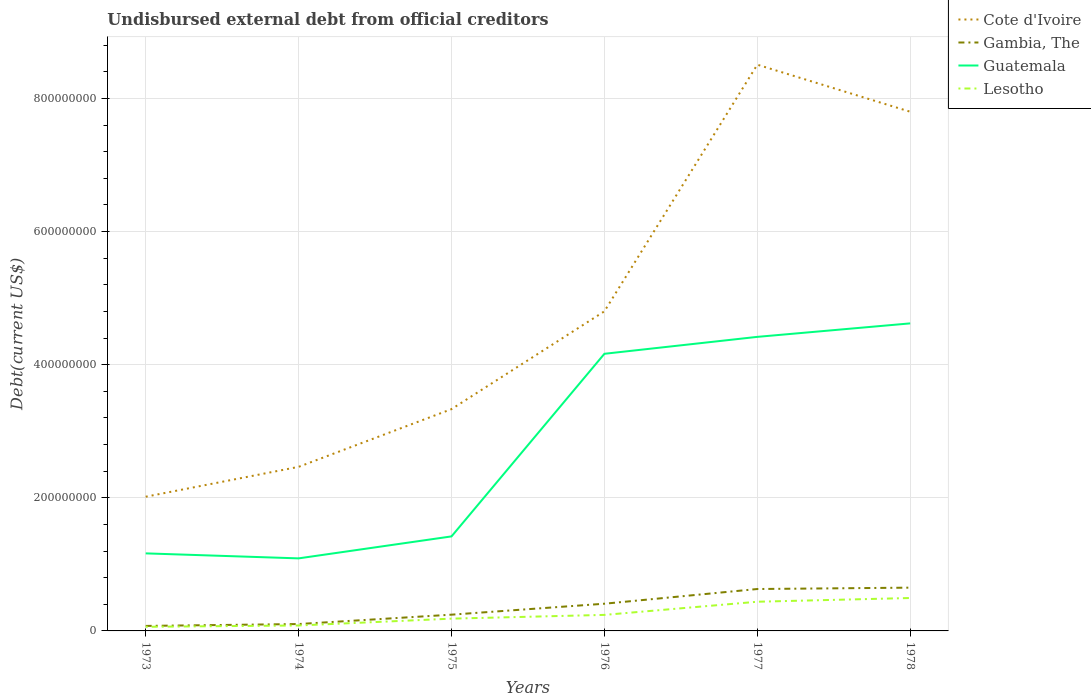How many different coloured lines are there?
Provide a short and direct response. 4. Is the number of lines equal to the number of legend labels?
Offer a very short reply. Yes. Across all years, what is the maximum total debt in Cote d'Ivoire?
Provide a short and direct response. 2.02e+08. What is the total total debt in Gambia, The in the graph?
Provide a short and direct response. -2.83e+06. What is the difference between the highest and the second highest total debt in Guatemala?
Offer a terse response. 3.53e+08. How many lines are there?
Ensure brevity in your answer.  4. Are the values on the major ticks of Y-axis written in scientific E-notation?
Your response must be concise. No. Where does the legend appear in the graph?
Offer a very short reply. Top right. How are the legend labels stacked?
Give a very brief answer. Vertical. What is the title of the graph?
Your answer should be very brief. Undisbursed external debt from official creditors. What is the label or title of the Y-axis?
Give a very brief answer. Debt(current US$). What is the Debt(current US$) in Cote d'Ivoire in 1973?
Keep it short and to the point. 2.02e+08. What is the Debt(current US$) in Gambia, The in 1973?
Ensure brevity in your answer.  7.52e+06. What is the Debt(current US$) of Guatemala in 1973?
Offer a very short reply. 1.17e+08. What is the Debt(current US$) in Lesotho in 1973?
Give a very brief answer. 6.19e+06. What is the Debt(current US$) of Cote d'Ivoire in 1974?
Give a very brief answer. 2.47e+08. What is the Debt(current US$) of Gambia, The in 1974?
Give a very brief answer. 1.03e+07. What is the Debt(current US$) in Guatemala in 1974?
Provide a succinct answer. 1.09e+08. What is the Debt(current US$) of Lesotho in 1974?
Make the answer very short. 8.19e+06. What is the Debt(current US$) in Cote d'Ivoire in 1975?
Your answer should be compact. 3.33e+08. What is the Debt(current US$) in Gambia, The in 1975?
Offer a very short reply. 2.44e+07. What is the Debt(current US$) in Guatemala in 1975?
Ensure brevity in your answer.  1.42e+08. What is the Debt(current US$) of Lesotho in 1975?
Give a very brief answer. 1.85e+07. What is the Debt(current US$) of Cote d'Ivoire in 1976?
Give a very brief answer. 4.80e+08. What is the Debt(current US$) in Gambia, The in 1976?
Your answer should be very brief. 4.09e+07. What is the Debt(current US$) of Guatemala in 1976?
Offer a terse response. 4.16e+08. What is the Debt(current US$) of Lesotho in 1976?
Keep it short and to the point. 2.41e+07. What is the Debt(current US$) in Cote d'Ivoire in 1977?
Give a very brief answer. 8.51e+08. What is the Debt(current US$) in Gambia, The in 1977?
Your response must be concise. 6.30e+07. What is the Debt(current US$) of Guatemala in 1977?
Your response must be concise. 4.42e+08. What is the Debt(current US$) in Lesotho in 1977?
Keep it short and to the point. 4.39e+07. What is the Debt(current US$) of Cote d'Ivoire in 1978?
Offer a very short reply. 7.80e+08. What is the Debt(current US$) of Gambia, The in 1978?
Offer a terse response. 6.50e+07. What is the Debt(current US$) in Guatemala in 1978?
Your answer should be very brief. 4.62e+08. What is the Debt(current US$) in Lesotho in 1978?
Provide a short and direct response. 4.95e+07. Across all years, what is the maximum Debt(current US$) of Cote d'Ivoire?
Give a very brief answer. 8.51e+08. Across all years, what is the maximum Debt(current US$) of Gambia, The?
Ensure brevity in your answer.  6.50e+07. Across all years, what is the maximum Debt(current US$) in Guatemala?
Provide a short and direct response. 4.62e+08. Across all years, what is the maximum Debt(current US$) in Lesotho?
Ensure brevity in your answer.  4.95e+07. Across all years, what is the minimum Debt(current US$) in Cote d'Ivoire?
Provide a short and direct response. 2.02e+08. Across all years, what is the minimum Debt(current US$) of Gambia, The?
Provide a short and direct response. 7.52e+06. Across all years, what is the minimum Debt(current US$) in Guatemala?
Ensure brevity in your answer.  1.09e+08. Across all years, what is the minimum Debt(current US$) of Lesotho?
Your response must be concise. 6.19e+06. What is the total Debt(current US$) in Cote d'Ivoire in the graph?
Provide a short and direct response. 2.89e+09. What is the total Debt(current US$) in Gambia, The in the graph?
Your answer should be compact. 2.11e+08. What is the total Debt(current US$) in Guatemala in the graph?
Your answer should be compact. 1.69e+09. What is the total Debt(current US$) of Lesotho in the graph?
Ensure brevity in your answer.  1.50e+08. What is the difference between the Debt(current US$) in Cote d'Ivoire in 1973 and that in 1974?
Provide a succinct answer. -4.49e+07. What is the difference between the Debt(current US$) in Gambia, The in 1973 and that in 1974?
Offer a very short reply. -2.83e+06. What is the difference between the Debt(current US$) of Guatemala in 1973 and that in 1974?
Keep it short and to the point. 7.50e+06. What is the difference between the Debt(current US$) in Lesotho in 1973 and that in 1974?
Provide a succinct answer. -2.00e+06. What is the difference between the Debt(current US$) in Cote d'Ivoire in 1973 and that in 1975?
Offer a terse response. -1.32e+08. What is the difference between the Debt(current US$) of Gambia, The in 1973 and that in 1975?
Your response must be concise. -1.69e+07. What is the difference between the Debt(current US$) in Guatemala in 1973 and that in 1975?
Provide a short and direct response. -2.55e+07. What is the difference between the Debt(current US$) of Lesotho in 1973 and that in 1975?
Your answer should be very brief. -1.23e+07. What is the difference between the Debt(current US$) in Cote d'Ivoire in 1973 and that in 1976?
Make the answer very short. -2.79e+08. What is the difference between the Debt(current US$) of Gambia, The in 1973 and that in 1976?
Make the answer very short. -3.34e+07. What is the difference between the Debt(current US$) of Guatemala in 1973 and that in 1976?
Your response must be concise. -3.00e+08. What is the difference between the Debt(current US$) of Lesotho in 1973 and that in 1976?
Make the answer very short. -1.79e+07. What is the difference between the Debt(current US$) in Cote d'Ivoire in 1973 and that in 1977?
Give a very brief answer. -6.49e+08. What is the difference between the Debt(current US$) in Gambia, The in 1973 and that in 1977?
Ensure brevity in your answer.  -5.54e+07. What is the difference between the Debt(current US$) of Guatemala in 1973 and that in 1977?
Give a very brief answer. -3.25e+08. What is the difference between the Debt(current US$) in Lesotho in 1973 and that in 1977?
Your response must be concise. -3.77e+07. What is the difference between the Debt(current US$) in Cote d'Ivoire in 1973 and that in 1978?
Ensure brevity in your answer.  -5.78e+08. What is the difference between the Debt(current US$) in Gambia, The in 1973 and that in 1978?
Your response must be concise. -5.75e+07. What is the difference between the Debt(current US$) in Guatemala in 1973 and that in 1978?
Ensure brevity in your answer.  -3.46e+08. What is the difference between the Debt(current US$) of Lesotho in 1973 and that in 1978?
Your answer should be very brief. -4.33e+07. What is the difference between the Debt(current US$) of Cote d'Ivoire in 1974 and that in 1975?
Offer a very short reply. -8.67e+07. What is the difference between the Debt(current US$) in Gambia, The in 1974 and that in 1975?
Your response must be concise. -1.41e+07. What is the difference between the Debt(current US$) in Guatemala in 1974 and that in 1975?
Give a very brief answer. -3.30e+07. What is the difference between the Debt(current US$) in Lesotho in 1974 and that in 1975?
Offer a very short reply. -1.03e+07. What is the difference between the Debt(current US$) in Cote d'Ivoire in 1974 and that in 1976?
Give a very brief answer. -2.34e+08. What is the difference between the Debt(current US$) in Gambia, The in 1974 and that in 1976?
Your answer should be compact. -3.05e+07. What is the difference between the Debt(current US$) of Guatemala in 1974 and that in 1976?
Provide a short and direct response. -3.07e+08. What is the difference between the Debt(current US$) of Lesotho in 1974 and that in 1976?
Your answer should be very brief. -1.59e+07. What is the difference between the Debt(current US$) in Cote d'Ivoire in 1974 and that in 1977?
Ensure brevity in your answer.  -6.04e+08. What is the difference between the Debt(current US$) in Gambia, The in 1974 and that in 1977?
Provide a short and direct response. -5.26e+07. What is the difference between the Debt(current US$) in Guatemala in 1974 and that in 1977?
Your response must be concise. -3.33e+08. What is the difference between the Debt(current US$) in Lesotho in 1974 and that in 1977?
Your answer should be compact. -3.57e+07. What is the difference between the Debt(current US$) in Cote d'Ivoire in 1974 and that in 1978?
Your answer should be very brief. -5.34e+08. What is the difference between the Debt(current US$) of Gambia, The in 1974 and that in 1978?
Offer a very short reply. -5.47e+07. What is the difference between the Debt(current US$) in Guatemala in 1974 and that in 1978?
Keep it short and to the point. -3.53e+08. What is the difference between the Debt(current US$) in Lesotho in 1974 and that in 1978?
Ensure brevity in your answer.  -4.13e+07. What is the difference between the Debt(current US$) of Cote d'Ivoire in 1975 and that in 1976?
Make the answer very short. -1.47e+08. What is the difference between the Debt(current US$) of Gambia, The in 1975 and that in 1976?
Offer a terse response. -1.64e+07. What is the difference between the Debt(current US$) of Guatemala in 1975 and that in 1976?
Your answer should be very brief. -2.74e+08. What is the difference between the Debt(current US$) of Lesotho in 1975 and that in 1976?
Provide a short and direct response. -5.64e+06. What is the difference between the Debt(current US$) in Cote d'Ivoire in 1975 and that in 1977?
Your response must be concise. -5.18e+08. What is the difference between the Debt(current US$) in Gambia, The in 1975 and that in 1977?
Provide a succinct answer. -3.85e+07. What is the difference between the Debt(current US$) of Guatemala in 1975 and that in 1977?
Provide a short and direct response. -3.00e+08. What is the difference between the Debt(current US$) of Lesotho in 1975 and that in 1977?
Provide a succinct answer. -2.54e+07. What is the difference between the Debt(current US$) in Cote d'Ivoire in 1975 and that in 1978?
Your answer should be compact. -4.47e+08. What is the difference between the Debt(current US$) of Gambia, The in 1975 and that in 1978?
Provide a short and direct response. -4.06e+07. What is the difference between the Debt(current US$) of Guatemala in 1975 and that in 1978?
Give a very brief answer. -3.20e+08. What is the difference between the Debt(current US$) in Lesotho in 1975 and that in 1978?
Your answer should be very brief. -3.10e+07. What is the difference between the Debt(current US$) of Cote d'Ivoire in 1976 and that in 1977?
Your response must be concise. -3.71e+08. What is the difference between the Debt(current US$) in Gambia, The in 1976 and that in 1977?
Keep it short and to the point. -2.21e+07. What is the difference between the Debt(current US$) in Guatemala in 1976 and that in 1977?
Keep it short and to the point. -2.54e+07. What is the difference between the Debt(current US$) of Lesotho in 1976 and that in 1977?
Ensure brevity in your answer.  -1.98e+07. What is the difference between the Debt(current US$) in Cote d'Ivoire in 1976 and that in 1978?
Give a very brief answer. -3.00e+08. What is the difference between the Debt(current US$) of Gambia, The in 1976 and that in 1978?
Ensure brevity in your answer.  -2.41e+07. What is the difference between the Debt(current US$) of Guatemala in 1976 and that in 1978?
Offer a terse response. -4.57e+07. What is the difference between the Debt(current US$) in Lesotho in 1976 and that in 1978?
Offer a terse response. -2.54e+07. What is the difference between the Debt(current US$) in Cote d'Ivoire in 1977 and that in 1978?
Give a very brief answer. 7.07e+07. What is the difference between the Debt(current US$) in Gambia, The in 1977 and that in 1978?
Your answer should be compact. -2.05e+06. What is the difference between the Debt(current US$) in Guatemala in 1977 and that in 1978?
Provide a short and direct response. -2.03e+07. What is the difference between the Debt(current US$) in Lesotho in 1977 and that in 1978?
Offer a terse response. -5.61e+06. What is the difference between the Debt(current US$) in Cote d'Ivoire in 1973 and the Debt(current US$) in Gambia, The in 1974?
Provide a succinct answer. 1.91e+08. What is the difference between the Debt(current US$) of Cote d'Ivoire in 1973 and the Debt(current US$) of Guatemala in 1974?
Your response must be concise. 9.26e+07. What is the difference between the Debt(current US$) of Cote d'Ivoire in 1973 and the Debt(current US$) of Lesotho in 1974?
Ensure brevity in your answer.  1.93e+08. What is the difference between the Debt(current US$) of Gambia, The in 1973 and the Debt(current US$) of Guatemala in 1974?
Your answer should be very brief. -1.01e+08. What is the difference between the Debt(current US$) of Gambia, The in 1973 and the Debt(current US$) of Lesotho in 1974?
Offer a terse response. -6.73e+05. What is the difference between the Debt(current US$) of Guatemala in 1973 and the Debt(current US$) of Lesotho in 1974?
Offer a very short reply. 1.08e+08. What is the difference between the Debt(current US$) in Cote d'Ivoire in 1973 and the Debt(current US$) in Gambia, The in 1975?
Keep it short and to the point. 1.77e+08. What is the difference between the Debt(current US$) of Cote d'Ivoire in 1973 and the Debt(current US$) of Guatemala in 1975?
Offer a very short reply. 5.96e+07. What is the difference between the Debt(current US$) of Cote d'Ivoire in 1973 and the Debt(current US$) of Lesotho in 1975?
Your answer should be compact. 1.83e+08. What is the difference between the Debt(current US$) in Gambia, The in 1973 and the Debt(current US$) in Guatemala in 1975?
Give a very brief answer. -1.35e+08. What is the difference between the Debt(current US$) of Gambia, The in 1973 and the Debt(current US$) of Lesotho in 1975?
Give a very brief answer. -1.09e+07. What is the difference between the Debt(current US$) of Guatemala in 1973 and the Debt(current US$) of Lesotho in 1975?
Your answer should be compact. 9.81e+07. What is the difference between the Debt(current US$) in Cote d'Ivoire in 1973 and the Debt(current US$) in Gambia, The in 1976?
Provide a short and direct response. 1.61e+08. What is the difference between the Debt(current US$) in Cote d'Ivoire in 1973 and the Debt(current US$) in Guatemala in 1976?
Your response must be concise. -2.15e+08. What is the difference between the Debt(current US$) of Cote d'Ivoire in 1973 and the Debt(current US$) of Lesotho in 1976?
Offer a very short reply. 1.78e+08. What is the difference between the Debt(current US$) of Gambia, The in 1973 and the Debt(current US$) of Guatemala in 1976?
Make the answer very short. -4.09e+08. What is the difference between the Debt(current US$) of Gambia, The in 1973 and the Debt(current US$) of Lesotho in 1976?
Ensure brevity in your answer.  -1.66e+07. What is the difference between the Debt(current US$) of Guatemala in 1973 and the Debt(current US$) of Lesotho in 1976?
Offer a very short reply. 9.24e+07. What is the difference between the Debt(current US$) of Cote d'Ivoire in 1973 and the Debt(current US$) of Gambia, The in 1977?
Offer a terse response. 1.39e+08. What is the difference between the Debt(current US$) in Cote d'Ivoire in 1973 and the Debt(current US$) in Guatemala in 1977?
Offer a very short reply. -2.40e+08. What is the difference between the Debt(current US$) in Cote d'Ivoire in 1973 and the Debt(current US$) in Lesotho in 1977?
Keep it short and to the point. 1.58e+08. What is the difference between the Debt(current US$) in Gambia, The in 1973 and the Debt(current US$) in Guatemala in 1977?
Offer a terse response. -4.34e+08. What is the difference between the Debt(current US$) in Gambia, The in 1973 and the Debt(current US$) in Lesotho in 1977?
Ensure brevity in your answer.  -3.63e+07. What is the difference between the Debt(current US$) in Guatemala in 1973 and the Debt(current US$) in Lesotho in 1977?
Give a very brief answer. 7.27e+07. What is the difference between the Debt(current US$) of Cote d'Ivoire in 1973 and the Debt(current US$) of Gambia, The in 1978?
Give a very brief answer. 1.37e+08. What is the difference between the Debt(current US$) of Cote d'Ivoire in 1973 and the Debt(current US$) of Guatemala in 1978?
Ensure brevity in your answer.  -2.60e+08. What is the difference between the Debt(current US$) of Cote d'Ivoire in 1973 and the Debt(current US$) of Lesotho in 1978?
Your answer should be very brief. 1.52e+08. What is the difference between the Debt(current US$) in Gambia, The in 1973 and the Debt(current US$) in Guatemala in 1978?
Your answer should be compact. -4.55e+08. What is the difference between the Debt(current US$) in Gambia, The in 1973 and the Debt(current US$) in Lesotho in 1978?
Offer a terse response. -4.19e+07. What is the difference between the Debt(current US$) in Guatemala in 1973 and the Debt(current US$) in Lesotho in 1978?
Make the answer very short. 6.70e+07. What is the difference between the Debt(current US$) in Cote d'Ivoire in 1974 and the Debt(current US$) in Gambia, The in 1975?
Provide a succinct answer. 2.22e+08. What is the difference between the Debt(current US$) in Cote d'Ivoire in 1974 and the Debt(current US$) in Guatemala in 1975?
Give a very brief answer. 1.05e+08. What is the difference between the Debt(current US$) in Cote d'Ivoire in 1974 and the Debt(current US$) in Lesotho in 1975?
Offer a terse response. 2.28e+08. What is the difference between the Debt(current US$) of Gambia, The in 1974 and the Debt(current US$) of Guatemala in 1975?
Ensure brevity in your answer.  -1.32e+08. What is the difference between the Debt(current US$) in Gambia, The in 1974 and the Debt(current US$) in Lesotho in 1975?
Your answer should be compact. -8.11e+06. What is the difference between the Debt(current US$) of Guatemala in 1974 and the Debt(current US$) of Lesotho in 1975?
Offer a terse response. 9.06e+07. What is the difference between the Debt(current US$) of Cote d'Ivoire in 1974 and the Debt(current US$) of Gambia, The in 1976?
Provide a succinct answer. 2.06e+08. What is the difference between the Debt(current US$) of Cote d'Ivoire in 1974 and the Debt(current US$) of Guatemala in 1976?
Offer a terse response. -1.70e+08. What is the difference between the Debt(current US$) in Cote d'Ivoire in 1974 and the Debt(current US$) in Lesotho in 1976?
Provide a short and direct response. 2.22e+08. What is the difference between the Debt(current US$) of Gambia, The in 1974 and the Debt(current US$) of Guatemala in 1976?
Your answer should be very brief. -4.06e+08. What is the difference between the Debt(current US$) in Gambia, The in 1974 and the Debt(current US$) in Lesotho in 1976?
Keep it short and to the point. -1.37e+07. What is the difference between the Debt(current US$) of Guatemala in 1974 and the Debt(current US$) of Lesotho in 1976?
Your response must be concise. 8.49e+07. What is the difference between the Debt(current US$) in Cote d'Ivoire in 1974 and the Debt(current US$) in Gambia, The in 1977?
Offer a very short reply. 1.84e+08. What is the difference between the Debt(current US$) of Cote d'Ivoire in 1974 and the Debt(current US$) of Guatemala in 1977?
Give a very brief answer. -1.95e+08. What is the difference between the Debt(current US$) in Cote d'Ivoire in 1974 and the Debt(current US$) in Lesotho in 1977?
Ensure brevity in your answer.  2.03e+08. What is the difference between the Debt(current US$) in Gambia, The in 1974 and the Debt(current US$) in Guatemala in 1977?
Offer a very short reply. -4.31e+08. What is the difference between the Debt(current US$) of Gambia, The in 1974 and the Debt(current US$) of Lesotho in 1977?
Your answer should be very brief. -3.35e+07. What is the difference between the Debt(current US$) in Guatemala in 1974 and the Debt(current US$) in Lesotho in 1977?
Offer a very short reply. 6.52e+07. What is the difference between the Debt(current US$) in Cote d'Ivoire in 1974 and the Debt(current US$) in Gambia, The in 1978?
Provide a succinct answer. 1.82e+08. What is the difference between the Debt(current US$) in Cote d'Ivoire in 1974 and the Debt(current US$) in Guatemala in 1978?
Keep it short and to the point. -2.16e+08. What is the difference between the Debt(current US$) of Cote d'Ivoire in 1974 and the Debt(current US$) of Lesotho in 1978?
Provide a short and direct response. 1.97e+08. What is the difference between the Debt(current US$) in Gambia, The in 1974 and the Debt(current US$) in Guatemala in 1978?
Your response must be concise. -4.52e+08. What is the difference between the Debt(current US$) in Gambia, The in 1974 and the Debt(current US$) in Lesotho in 1978?
Keep it short and to the point. -3.91e+07. What is the difference between the Debt(current US$) in Guatemala in 1974 and the Debt(current US$) in Lesotho in 1978?
Make the answer very short. 5.95e+07. What is the difference between the Debt(current US$) in Cote d'Ivoire in 1975 and the Debt(current US$) in Gambia, The in 1976?
Make the answer very short. 2.92e+08. What is the difference between the Debt(current US$) of Cote d'Ivoire in 1975 and the Debt(current US$) of Guatemala in 1976?
Give a very brief answer. -8.32e+07. What is the difference between the Debt(current US$) of Cote d'Ivoire in 1975 and the Debt(current US$) of Lesotho in 1976?
Your answer should be very brief. 3.09e+08. What is the difference between the Debt(current US$) of Gambia, The in 1975 and the Debt(current US$) of Guatemala in 1976?
Ensure brevity in your answer.  -3.92e+08. What is the difference between the Debt(current US$) in Gambia, The in 1975 and the Debt(current US$) in Lesotho in 1976?
Your answer should be very brief. 3.34e+05. What is the difference between the Debt(current US$) in Guatemala in 1975 and the Debt(current US$) in Lesotho in 1976?
Ensure brevity in your answer.  1.18e+08. What is the difference between the Debt(current US$) in Cote d'Ivoire in 1975 and the Debt(current US$) in Gambia, The in 1977?
Give a very brief answer. 2.70e+08. What is the difference between the Debt(current US$) of Cote d'Ivoire in 1975 and the Debt(current US$) of Guatemala in 1977?
Provide a short and direct response. -1.09e+08. What is the difference between the Debt(current US$) of Cote d'Ivoire in 1975 and the Debt(current US$) of Lesotho in 1977?
Your response must be concise. 2.89e+08. What is the difference between the Debt(current US$) of Gambia, The in 1975 and the Debt(current US$) of Guatemala in 1977?
Provide a succinct answer. -4.17e+08. What is the difference between the Debt(current US$) of Gambia, The in 1975 and the Debt(current US$) of Lesotho in 1977?
Offer a terse response. -1.94e+07. What is the difference between the Debt(current US$) in Guatemala in 1975 and the Debt(current US$) in Lesotho in 1977?
Give a very brief answer. 9.82e+07. What is the difference between the Debt(current US$) in Cote d'Ivoire in 1975 and the Debt(current US$) in Gambia, The in 1978?
Make the answer very short. 2.68e+08. What is the difference between the Debt(current US$) in Cote d'Ivoire in 1975 and the Debt(current US$) in Guatemala in 1978?
Offer a terse response. -1.29e+08. What is the difference between the Debt(current US$) of Cote d'Ivoire in 1975 and the Debt(current US$) of Lesotho in 1978?
Make the answer very short. 2.84e+08. What is the difference between the Debt(current US$) of Gambia, The in 1975 and the Debt(current US$) of Guatemala in 1978?
Provide a short and direct response. -4.38e+08. What is the difference between the Debt(current US$) of Gambia, The in 1975 and the Debt(current US$) of Lesotho in 1978?
Your response must be concise. -2.50e+07. What is the difference between the Debt(current US$) of Guatemala in 1975 and the Debt(current US$) of Lesotho in 1978?
Make the answer very short. 9.26e+07. What is the difference between the Debt(current US$) of Cote d'Ivoire in 1976 and the Debt(current US$) of Gambia, The in 1977?
Offer a very short reply. 4.17e+08. What is the difference between the Debt(current US$) in Cote d'Ivoire in 1976 and the Debt(current US$) in Guatemala in 1977?
Keep it short and to the point. 3.84e+07. What is the difference between the Debt(current US$) of Cote d'Ivoire in 1976 and the Debt(current US$) of Lesotho in 1977?
Provide a short and direct response. 4.36e+08. What is the difference between the Debt(current US$) in Gambia, The in 1976 and the Debt(current US$) in Guatemala in 1977?
Your answer should be very brief. -4.01e+08. What is the difference between the Debt(current US$) of Gambia, The in 1976 and the Debt(current US$) of Lesotho in 1977?
Keep it short and to the point. -2.98e+06. What is the difference between the Debt(current US$) of Guatemala in 1976 and the Debt(current US$) of Lesotho in 1977?
Make the answer very short. 3.73e+08. What is the difference between the Debt(current US$) in Cote d'Ivoire in 1976 and the Debt(current US$) in Gambia, The in 1978?
Make the answer very short. 4.15e+08. What is the difference between the Debt(current US$) in Cote d'Ivoire in 1976 and the Debt(current US$) in Guatemala in 1978?
Make the answer very short. 1.81e+07. What is the difference between the Debt(current US$) of Cote d'Ivoire in 1976 and the Debt(current US$) of Lesotho in 1978?
Provide a succinct answer. 4.31e+08. What is the difference between the Debt(current US$) in Gambia, The in 1976 and the Debt(current US$) in Guatemala in 1978?
Make the answer very short. -4.21e+08. What is the difference between the Debt(current US$) of Gambia, The in 1976 and the Debt(current US$) of Lesotho in 1978?
Offer a very short reply. -8.59e+06. What is the difference between the Debt(current US$) of Guatemala in 1976 and the Debt(current US$) of Lesotho in 1978?
Make the answer very short. 3.67e+08. What is the difference between the Debt(current US$) of Cote d'Ivoire in 1977 and the Debt(current US$) of Gambia, The in 1978?
Give a very brief answer. 7.86e+08. What is the difference between the Debt(current US$) in Cote d'Ivoire in 1977 and the Debt(current US$) in Guatemala in 1978?
Your answer should be very brief. 3.89e+08. What is the difference between the Debt(current US$) of Cote d'Ivoire in 1977 and the Debt(current US$) of Lesotho in 1978?
Ensure brevity in your answer.  8.01e+08. What is the difference between the Debt(current US$) of Gambia, The in 1977 and the Debt(current US$) of Guatemala in 1978?
Offer a very short reply. -3.99e+08. What is the difference between the Debt(current US$) in Gambia, The in 1977 and the Debt(current US$) in Lesotho in 1978?
Keep it short and to the point. 1.35e+07. What is the difference between the Debt(current US$) of Guatemala in 1977 and the Debt(current US$) of Lesotho in 1978?
Ensure brevity in your answer.  3.92e+08. What is the average Debt(current US$) in Cote d'Ivoire per year?
Give a very brief answer. 4.82e+08. What is the average Debt(current US$) of Gambia, The per year?
Give a very brief answer. 3.52e+07. What is the average Debt(current US$) in Guatemala per year?
Provide a short and direct response. 2.81e+08. What is the average Debt(current US$) in Lesotho per year?
Provide a short and direct response. 2.50e+07. In the year 1973, what is the difference between the Debt(current US$) in Cote d'Ivoire and Debt(current US$) in Gambia, The?
Make the answer very short. 1.94e+08. In the year 1973, what is the difference between the Debt(current US$) in Cote d'Ivoire and Debt(current US$) in Guatemala?
Make the answer very short. 8.51e+07. In the year 1973, what is the difference between the Debt(current US$) of Cote d'Ivoire and Debt(current US$) of Lesotho?
Your answer should be compact. 1.95e+08. In the year 1973, what is the difference between the Debt(current US$) of Gambia, The and Debt(current US$) of Guatemala?
Keep it short and to the point. -1.09e+08. In the year 1973, what is the difference between the Debt(current US$) in Gambia, The and Debt(current US$) in Lesotho?
Your answer should be compact. 1.33e+06. In the year 1973, what is the difference between the Debt(current US$) of Guatemala and Debt(current US$) of Lesotho?
Offer a terse response. 1.10e+08. In the year 1974, what is the difference between the Debt(current US$) of Cote d'Ivoire and Debt(current US$) of Gambia, The?
Your answer should be very brief. 2.36e+08. In the year 1974, what is the difference between the Debt(current US$) in Cote d'Ivoire and Debt(current US$) in Guatemala?
Your answer should be compact. 1.38e+08. In the year 1974, what is the difference between the Debt(current US$) of Cote d'Ivoire and Debt(current US$) of Lesotho?
Keep it short and to the point. 2.38e+08. In the year 1974, what is the difference between the Debt(current US$) of Gambia, The and Debt(current US$) of Guatemala?
Give a very brief answer. -9.87e+07. In the year 1974, what is the difference between the Debt(current US$) of Gambia, The and Debt(current US$) of Lesotho?
Provide a short and direct response. 2.15e+06. In the year 1974, what is the difference between the Debt(current US$) of Guatemala and Debt(current US$) of Lesotho?
Provide a short and direct response. 1.01e+08. In the year 1975, what is the difference between the Debt(current US$) of Cote d'Ivoire and Debt(current US$) of Gambia, The?
Make the answer very short. 3.09e+08. In the year 1975, what is the difference between the Debt(current US$) in Cote d'Ivoire and Debt(current US$) in Guatemala?
Provide a short and direct response. 1.91e+08. In the year 1975, what is the difference between the Debt(current US$) of Cote d'Ivoire and Debt(current US$) of Lesotho?
Provide a short and direct response. 3.15e+08. In the year 1975, what is the difference between the Debt(current US$) in Gambia, The and Debt(current US$) in Guatemala?
Give a very brief answer. -1.18e+08. In the year 1975, what is the difference between the Debt(current US$) in Gambia, The and Debt(current US$) in Lesotho?
Your response must be concise. 5.97e+06. In the year 1975, what is the difference between the Debt(current US$) in Guatemala and Debt(current US$) in Lesotho?
Provide a succinct answer. 1.24e+08. In the year 1976, what is the difference between the Debt(current US$) in Cote d'Ivoire and Debt(current US$) in Gambia, The?
Your answer should be compact. 4.39e+08. In the year 1976, what is the difference between the Debt(current US$) of Cote d'Ivoire and Debt(current US$) of Guatemala?
Ensure brevity in your answer.  6.38e+07. In the year 1976, what is the difference between the Debt(current US$) of Cote d'Ivoire and Debt(current US$) of Lesotho?
Provide a succinct answer. 4.56e+08. In the year 1976, what is the difference between the Debt(current US$) in Gambia, The and Debt(current US$) in Guatemala?
Your answer should be very brief. -3.76e+08. In the year 1976, what is the difference between the Debt(current US$) of Gambia, The and Debt(current US$) of Lesotho?
Ensure brevity in your answer.  1.68e+07. In the year 1976, what is the difference between the Debt(current US$) of Guatemala and Debt(current US$) of Lesotho?
Your answer should be compact. 3.92e+08. In the year 1977, what is the difference between the Debt(current US$) of Cote d'Ivoire and Debt(current US$) of Gambia, The?
Your response must be concise. 7.88e+08. In the year 1977, what is the difference between the Debt(current US$) of Cote d'Ivoire and Debt(current US$) of Guatemala?
Your response must be concise. 4.09e+08. In the year 1977, what is the difference between the Debt(current US$) of Cote d'Ivoire and Debt(current US$) of Lesotho?
Your response must be concise. 8.07e+08. In the year 1977, what is the difference between the Debt(current US$) in Gambia, The and Debt(current US$) in Guatemala?
Offer a very short reply. -3.79e+08. In the year 1977, what is the difference between the Debt(current US$) in Gambia, The and Debt(current US$) in Lesotho?
Your response must be concise. 1.91e+07. In the year 1977, what is the difference between the Debt(current US$) in Guatemala and Debt(current US$) in Lesotho?
Offer a terse response. 3.98e+08. In the year 1978, what is the difference between the Debt(current US$) of Cote d'Ivoire and Debt(current US$) of Gambia, The?
Provide a short and direct response. 7.15e+08. In the year 1978, what is the difference between the Debt(current US$) of Cote d'Ivoire and Debt(current US$) of Guatemala?
Ensure brevity in your answer.  3.18e+08. In the year 1978, what is the difference between the Debt(current US$) of Cote d'Ivoire and Debt(current US$) of Lesotho?
Provide a succinct answer. 7.31e+08. In the year 1978, what is the difference between the Debt(current US$) of Gambia, The and Debt(current US$) of Guatemala?
Offer a very short reply. -3.97e+08. In the year 1978, what is the difference between the Debt(current US$) of Gambia, The and Debt(current US$) of Lesotho?
Your answer should be compact. 1.56e+07. In the year 1978, what is the difference between the Debt(current US$) in Guatemala and Debt(current US$) in Lesotho?
Offer a terse response. 4.13e+08. What is the ratio of the Debt(current US$) in Cote d'Ivoire in 1973 to that in 1974?
Keep it short and to the point. 0.82. What is the ratio of the Debt(current US$) of Gambia, The in 1973 to that in 1974?
Provide a short and direct response. 0.73. What is the ratio of the Debt(current US$) in Guatemala in 1973 to that in 1974?
Offer a terse response. 1.07. What is the ratio of the Debt(current US$) of Lesotho in 1973 to that in 1974?
Your answer should be very brief. 0.76. What is the ratio of the Debt(current US$) in Cote d'Ivoire in 1973 to that in 1975?
Offer a very short reply. 0.61. What is the ratio of the Debt(current US$) of Gambia, The in 1973 to that in 1975?
Give a very brief answer. 0.31. What is the ratio of the Debt(current US$) in Guatemala in 1973 to that in 1975?
Keep it short and to the point. 0.82. What is the ratio of the Debt(current US$) of Lesotho in 1973 to that in 1975?
Your answer should be compact. 0.34. What is the ratio of the Debt(current US$) in Cote d'Ivoire in 1973 to that in 1976?
Provide a short and direct response. 0.42. What is the ratio of the Debt(current US$) of Gambia, The in 1973 to that in 1976?
Provide a short and direct response. 0.18. What is the ratio of the Debt(current US$) of Guatemala in 1973 to that in 1976?
Provide a short and direct response. 0.28. What is the ratio of the Debt(current US$) of Lesotho in 1973 to that in 1976?
Your answer should be compact. 0.26. What is the ratio of the Debt(current US$) of Cote d'Ivoire in 1973 to that in 1977?
Your answer should be compact. 0.24. What is the ratio of the Debt(current US$) of Gambia, The in 1973 to that in 1977?
Provide a succinct answer. 0.12. What is the ratio of the Debt(current US$) in Guatemala in 1973 to that in 1977?
Offer a terse response. 0.26. What is the ratio of the Debt(current US$) of Lesotho in 1973 to that in 1977?
Offer a very short reply. 0.14. What is the ratio of the Debt(current US$) in Cote d'Ivoire in 1973 to that in 1978?
Ensure brevity in your answer.  0.26. What is the ratio of the Debt(current US$) of Gambia, The in 1973 to that in 1978?
Ensure brevity in your answer.  0.12. What is the ratio of the Debt(current US$) of Guatemala in 1973 to that in 1978?
Your answer should be very brief. 0.25. What is the ratio of the Debt(current US$) in Lesotho in 1973 to that in 1978?
Provide a short and direct response. 0.13. What is the ratio of the Debt(current US$) of Cote d'Ivoire in 1974 to that in 1975?
Your answer should be very brief. 0.74. What is the ratio of the Debt(current US$) in Gambia, The in 1974 to that in 1975?
Provide a succinct answer. 0.42. What is the ratio of the Debt(current US$) in Guatemala in 1974 to that in 1975?
Give a very brief answer. 0.77. What is the ratio of the Debt(current US$) of Lesotho in 1974 to that in 1975?
Give a very brief answer. 0.44. What is the ratio of the Debt(current US$) of Cote d'Ivoire in 1974 to that in 1976?
Give a very brief answer. 0.51. What is the ratio of the Debt(current US$) in Gambia, The in 1974 to that in 1976?
Offer a very short reply. 0.25. What is the ratio of the Debt(current US$) of Guatemala in 1974 to that in 1976?
Offer a very short reply. 0.26. What is the ratio of the Debt(current US$) in Lesotho in 1974 to that in 1976?
Give a very brief answer. 0.34. What is the ratio of the Debt(current US$) in Cote d'Ivoire in 1974 to that in 1977?
Provide a succinct answer. 0.29. What is the ratio of the Debt(current US$) in Gambia, The in 1974 to that in 1977?
Provide a succinct answer. 0.16. What is the ratio of the Debt(current US$) in Guatemala in 1974 to that in 1977?
Your response must be concise. 0.25. What is the ratio of the Debt(current US$) in Lesotho in 1974 to that in 1977?
Keep it short and to the point. 0.19. What is the ratio of the Debt(current US$) of Cote d'Ivoire in 1974 to that in 1978?
Your answer should be compact. 0.32. What is the ratio of the Debt(current US$) of Gambia, The in 1974 to that in 1978?
Offer a terse response. 0.16. What is the ratio of the Debt(current US$) of Guatemala in 1974 to that in 1978?
Provide a short and direct response. 0.24. What is the ratio of the Debt(current US$) of Lesotho in 1974 to that in 1978?
Make the answer very short. 0.17. What is the ratio of the Debt(current US$) of Cote d'Ivoire in 1975 to that in 1976?
Provide a short and direct response. 0.69. What is the ratio of the Debt(current US$) of Gambia, The in 1975 to that in 1976?
Make the answer very short. 0.6. What is the ratio of the Debt(current US$) of Guatemala in 1975 to that in 1976?
Your answer should be very brief. 0.34. What is the ratio of the Debt(current US$) in Lesotho in 1975 to that in 1976?
Ensure brevity in your answer.  0.77. What is the ratio of the Debt(current US$) in Cote d'Ivoire in 1975 to that in 1977?
Offer a very short reply. 0.39. What is the ratio of the Debt(current US$) in Gambia, The in 1975 to that in 1977?
Make the answer very short. 0.39. What is the ratio of the Debt(current US$) in Guatemala in 1975 to that in 1977?
Offer a terse response. 0.32. What is the ratio of the Debt(current US$) of Lesotho in 1975 to that in 1977?
Give a very brief answer. 0.42. What is the ratio of the Debt(current US$) in Cote d'Ivoire in 1975 to that in 1978?
Your answer should be very brief. 0.43. What is the ratio of the Debt(current US$) of Gambia, The in 1975 to that in 1978?
Your response must be concise. 0.38. What is the ratio of the Debt(current US$) of Guatemala in 1975 to that in 1978?
Offer a very short reply. 0.31. What is the ratio of the Debt(current US$) in Lesotho in 1975 to that in 1978?
Make the answer very short. 0.37. What is the ratio of the Debt(current US$) of Cote d'Ivoire in 1976 to that in 1977?
Your answer should be very brief. 0.56. What is the ratio of the Debt(current US$) in Gambia, The in 1976 to that in 1977?
Give a very brief answer. 0.65. What is the ratio of the Debt(current US$) in Guatemala in 1976 to that in 1977?
Provide a short and direct response. 0.94. What is the ratio of the Debt(current US$) in Lesotho in 1976 to that in 1977?
Provide a succinct answer. 0.55. What is the ratio of the Debt(current US$) of Cote d'Ivoire in 1976 to that in 1978?
Provide a short and direct response. 0.62. What is the ratio of the Debt(current US$) in Gambia, The in 1976 to that in 1978?
Ensure brevity in your answer.  0.63. What is the ratio of the Debt(current US$) in Guatemala in 1976 to that in 1978?
Your answer should be very brief. 0.9. What is the ratio of the Debt(current US$) of Lesotho in 1976 to that in 1978?
Your answer should be very brief. 0.49. What is the ratio of the Debt(current US$) of Cote d'Ivoire in 1977 to that in 1978?
Offer a terse response. 1.09. What is the ratio of the Debt(current US$) in Gambia, The in 1977 to that in 1978?
Your response must be concise. 0.97. What is the ratio of the Debt(current US$) in Guatemala in 1977 to that in 1978?
Keep it short and to the point. 0.96. What is the ratio of the Debt(current US$) of Lesotho in 1977 to that in 1978?
Keep it short and to the point. 0.89. What is the difference between the highest and the second highest Debt(current US$) in Cote d'Ivoire?
Make the answer very short. 7.07e+07. What is the difference between the highest and the second highest Debt(current US$) in Gambia, The?
Make the answer very short. 2.05e+06. What is the difference between the highest and the second highest Debt(current US$) of Guatemala?
Keep it short and to the point. 2.03e+07. What is the difference between the highest and the second highest Debt(current US$) in Lesotho?
Provide a short and direct response. 5.61e+06. What is the difference between the highest and the lowest Debt(current US$) of Cote d'Ivoire?
Ensure brevity in your answer.  6.49e+08. What is the difference between the highest and the lowest Debt(current US$) in Gambia, The?
Your answer should be compact. 5.75e+07. What is the difference between the highest and the lowest Debt(current US$) of Guatemala?
Keep it short and to the point. 3.53e+08. What is the difference between the highest and the lowest Debt(current US$) of Lesotho?
Give a very brief answer. 4.33e+07. 